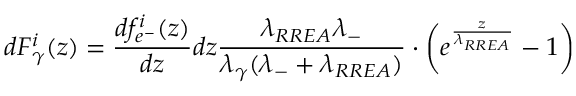<formula> <loc_0><loc_0><loc_500><loc_500>d F _ { \gamma } ^ { i } ( z ) = \frac { d f _ { e ^ { - } } ^ { i } ( z ) } { d z } d z \frac { \lambda _ { R R E A } \lambda _ { - } } { \lambda _ { \gamma } ( \lambda _ { - } + \lambda _ { R R E A } ) } \cdot \left ( e ^ { \frac { z } { \lambda _ { R R E A } } } - 1 \right )</formula> 